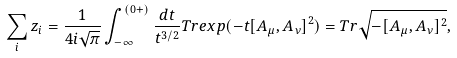Convert formula to latex. <formula><loc_0><loc_0><loc_500><loc_500>\sum _ { i } z _ { i } = \frac { 1 } { 4 i \sqrt { \pi } } \int _ { - \infty } ^ { ( 0 + ) } \frac { d t } { t ^ { 3 / 2 } } T r e x p ( - t [ A _ { \mu } , A _ { \nu } ] ^ { 2 } ) = T r \sqrt { - [ A _ { \mu } , A _ { \nu } ] ^ { 2 } } ,</formula> 